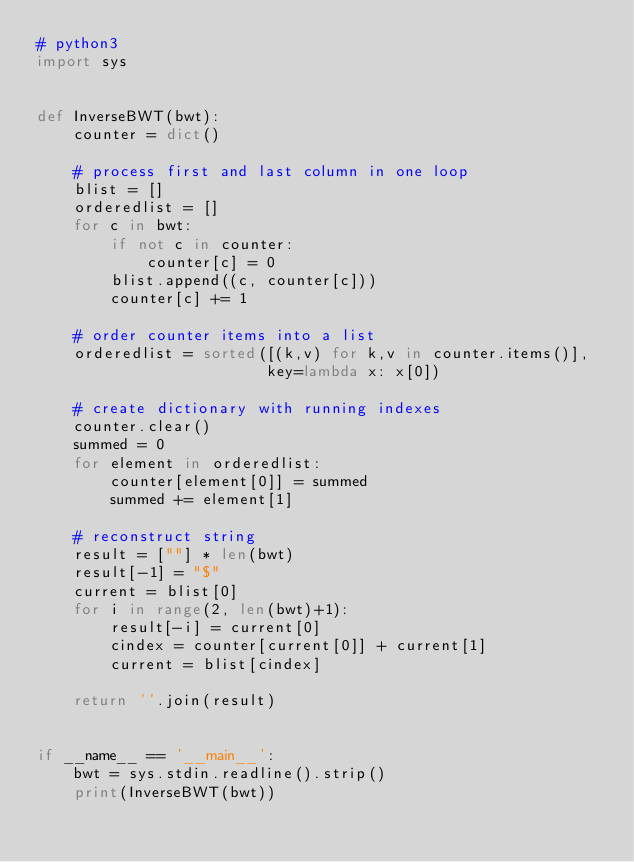Convert code to text. <code><loc_0><loc_0><loc_500><loc_500><_Python_># python3
import sys


def InverseBWT(bwt):
    counter = dict()

    # process first and last column in one loop
    blist = []
    orderedlist = []
    for c in bwt:
        if not c in counter:
            counter[c] = 0
        blist.append((c, counter[c]))
        counter[c] += 1

    # order counter items into a list
    orderedlist = sorted([(k,v) for k,v in counter.items()], 
                         key=lambda x: x[0])
    
    # create dictionary with running indexes
    counter.clear()
    summed = 0
    for element in orderedlist:
        counter[element[0]] = summed
        summed += element[1]

    # reconstruct string
    result = [""] * len(bwt)
    result[-1] = "$"
    current = blist[0]
    for i in range(2, len(bwt)+1):
        result[-i] = current[0]
        cindex = counter[current[0]] + current[1]
        current = blist[cindex]

    return ''.join(result)


if __name__ == '__main__':
    bwt = sys.stdin.readline().strip()
    print(InverseBWT(bwt))</code> 